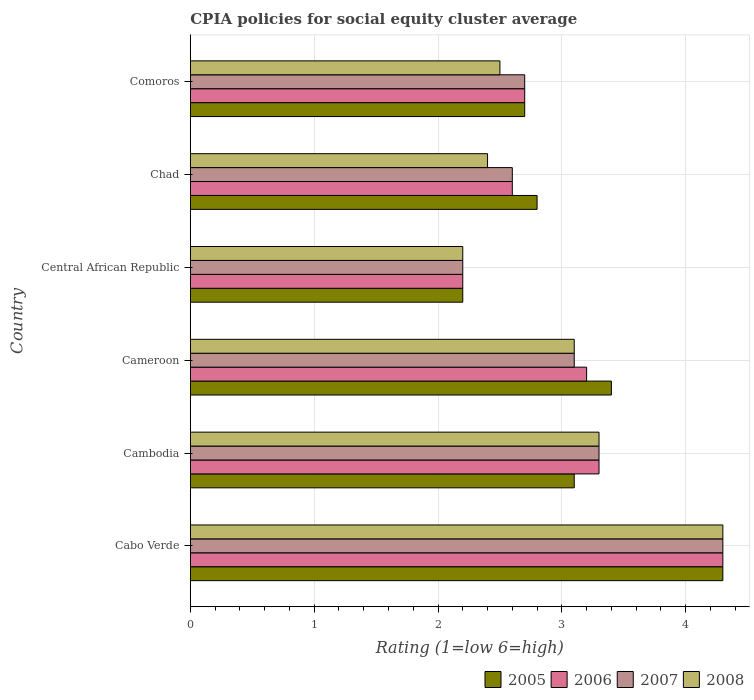How many different coloured bars are there?
Your answer should be very brief. 4. How many groups of bars are there?
Provide a short and direct response. 6. Are the number of bars per tick equal to the number of legend labels?
Ensure brevity in your answer.  Yes. How many bars are there on the 1st tick from the bottom?
Offer a terse response. 4. What is the label of the 2nd group of bars from the top?
Your response must be concise. Chad. In how many cases, is the number of bars for a given country not equal to the number of legend labels?
Provide a succinct answer. 0. What is the CPIA rating in 2007 in Cameroon?
Make the answer very short. 3.1. Across all countries, what is the maximum CPIA rating in 2005?
Your answer should be compact. 4.3. Across all countries, what is the minimum CPIA rating in 2006?
Make the answer very short. 2.2. In which country was the CPIA rating in 2008 maximum?
Your response must be concise. Cabo Verde. In which country was the CPIA rating in 2008 minimum?
Provide a short and direct response. Central African Republic. What is the total CPIA rating in 2008 in the graph?
Offer a very short reply. 17.8. What is the difference between the CPIA rating in 2008 in Cabo Verde and that in Central African Republic?
Offer a very short reply. 2.1. What is the difference between the CPIA rating in 2005 in Chad and the CPIA rating in 2007 in Cameroon?
Offer a terse response. -0.3. What is the average CPIA rating in 2006 per country?
Keep it short and to the point. 3.05. In how many countries, is the CPIA rating in 2005 greater than 2.8 ?
Provide a short and direct response. 3. What is the ratio of the CPIA rating in 2005 in Chad to that in Comoros?
Your answer should be compact. 1.04. Is the CPIA rating in 2007 in Cameroon less than that in Chad?
Offer a very short reply. No. Is the difference between the CPIA rating in 2006 in Cambodia and Cameroon greater than the difference between the CPIA rating in 2007 in Cambodia and Cameroon?
Your answer should be compact. No. What is the difference between the highest and the lowest CPIA rating in 2008?
Ensure brevity in your answer.  2.1. In how many countries, is the CPIA rating in 2007 greater than the average CPIA rating in 2007 taken over all countries?
Make the answer very short. 3. What does the 2nd bar from the top in Cameroon represents?
Keep it short and to the point. 2007. Are all the bars in the graph horizontal?
Provide a succinct answer. Yes. How many countries are there in the graph?
Give a very brief answer. 6. What is the difference between two consecutive major ticks on the X-axis?
Offer a very short reply. 1. Are the values on the major ticks of X-axis written in scientific E-notation?
Ensure brevity in your answer.  No. Does the graph contain any zero values?
Keep it short and to the point. No. Does the graph contain grids?
Your answer should be very brief. Yes. Where does the legend appear in the graph?
Give a very brief answer. Bottom right. How are the legend labels stacked?
Your answer should be compact. Horizontal. What is the title of the graph?
Give a very brief answer. CPIA policies for social equity cluster average. What is the label or title of the X-axis?
Your answer should be very brief. Rating (1=low 6=high). What is the Rating (1=low 6=high) of 2005 in Cabo Verde?
Your answer should be very brief. 4.3. What is the Rating (1=low 6=high) in 2006 in Cabo Verde?
Provide a short and direct response. 4.3. What is the Rating (1=low 6=high) in 2008 in Cabo Verde?
Keep it short and to the point. 4.3. What is the Rating (1=low 6=high) of 2005 in Cambodia?
Make the answer very short. 3.1. What is the Rating (1=low 6=high) of 2006 in Cambodia?
Ensure brevity in your answer.  3.3. What is the Rating (1=low 6=high) in 2007 in Cambodia?
Offer a terse response. 3.3. What is the Rating (1=low 6=high) in 2006 in Cameroon?
Ensure brevity in your answer.  3.2. What is the Rating (1=low 6=high) in 2005 in Central African Republic?
Provide a short and direct response. 2.2. What is the Rating (1=low 6=high) of 2005 in Chad?
Give a very brief answer. 2.8. What is the Rating (1=low 6=high) of 2006 in Chad?
Keep it short and to the point. 2.6. What is the Rating (1=low 6=high) in 2008 in Chad?
Make the answer very short. 2.4. What is the Rating (1=low 6=high) of 2005 in Comoros?
Your answer should be very brief. 2.7. What is the Rating (1=low 6=high) of 2006 in Comoros?
Your answer should be very brief. 2.7. What is the Rating (1=low 6=high) of 2007 in Comoros?
Your response must be concise. 2.7. What is the Rating (1=low 6=high) of 2008 in Comoros?
Make the answer very short. 2.5. Across all countries, what is the maximum Rating (1=low 6=high) of 2006?
Offer a very short reply. 4.3. Across all countries, what is the maximum Rating (1=low 6=high) of 2007?
Make the answer very short. 4.3. Across all countries, what is the maximum Rating (1=low 6=high) of 2008?
Provide a short and direct response. 4.3. Across all countries, what is the minimum Rating (1=low 6=high) of 2007?
Offer a terse response. 2.2. What is the total Rating (1=low 6=high) of 2005 in the graph?
Your response must be concise. 18.5. What is the total Rating (1=low 6=high) in 2007 in the graph?
Offer a very short reply. 18.2. What is the difference between the Rating (1=low 6=high) of 2006 in Cabo Verde and that in Cambodia?
Keep it short and to the point. 1. What is the difference between the Rating (1=low 6=high) of 2007 in Cabo Verde and that in Cambodia?
Your answer should be compact. 1. What is the difference between the Rating (1=low 6=high) in 2007 in Cabo Verde and that in Cameroon?
Offer a very short reply. 1.2. What is the difference between the Rating (1=low 6=high) in 2008 in Cabo Verde and that in Cameroon?
Ensure brevity in your answer.  1.2. What is the difference between the Rating (1=low 6=high) of 2008 in Cabo Verde and that in Central African Republic?
Provide a succinct answer. 2.1. What is the difference between the Rating (1=low 6=high) of 2005 in Cabo Verde and that in Chad?
Make the answer very short. 1.5. What is the difference between the Rating (1=low 6=high) of 2007 in Cabo Verde and that in Chad?
Your answer should be compact. 1.7. What is the difference between the Rating (1=low 6=high) of 2008 in Cabo Verde and that in Chad?
Offer a terse response. 1.9. What is the difference between the Rating (1=low 6=high) of 2006 in Cabo Verde and that in Comoros?
Give a very brief answer. 1.6. What is the difference between the Rating (1=low 6=high) in 2007 in Cabo Verde and that in Comoros?
Provide a short and direct response. 1.6. What is the difference between the Rating (1=low 6=high) in 2008 in Cabo Verde and that in Comoros?
Make the answer very short. 1.8. What is the difference between the Rating (1=low 6=high) of 2006 in Cambodia and that in Cameroon?
Provide a succinct answer. 0.1. What is the difference between the Rating (1=low 6=high) of 2008 in Cambodia and that in Cameroon?
Ensure brevity in your answer.  0.2. What is the difference between the Rating (1=low 6=high) of 2006 in Cambodia and that in Central African Republic?
Offer a very short reply. 1.1. What is the difference between the Rating (1=low 6=high) of 2007 in Cambodia and that in Central African Republic?
Provide a short and direct response. 1.1. What is the difference between the Rating (1=low 6=high) of 2008 in Cambodia and that in Central African Republic?
Your response must be concise. 1.1. What is the difference between the Rating (1=low 6=high) in 2008 in Cambodia and that in Chad?
Your response must be concise. 0.9. What is the difference between the Rating (1=low 6=high) in 2005 in Cambodia and that in Comoros?
Give a very brief answer. 0.4. What is the difference between the Rating (1=low 6=high) in 2005 in Cameroon and that in Central African Republic?
Keep it short and to the point. 1.2. What is the difference between the Rating (1=low 6=high) in 2007 in Cameroon and that in Central African Republic?
Give a very brief answer. 0.9. What is the difference between the Rating (1=low 6=high) of 2006 in Cameroon and that in Chad?
Your answer should be compact. 0.6. What is the difference between the Rating (1=low 6=high) of 2007 in Cameroon and that in Chad?
Make the answer very short. 0.5. What is the difference between the Rating (1=low 6=high) of 2007 in Cameroon and that in Comoros?
Give a very brief answer. 0.4. What is the difference between the Rating (1=low 6=high) of 2008 in Cameroon and that in Comoros?
Provide a short and direct response. 0.6. What is the difference between the Rating (1=low 6=high) of 2006 in Central African Republic and that in Chad?
Ensure brevity in your answer.  -0.4. What is the difference between the Rating (1=low 6=high) in 2007 in Central African Republic and that in Chad?
Provide a short and direct response. -0.4. What is the difference between the Rating (1=low 6=high) in 2006 in Central African Republic and that in Comoros?
Your answer should be compact. -0.5. What is the difference between the Rating (1=low 6=high) in 2005 in Chad and that in Comoros?
Your answer should be very brief. 0.1. What is the difference between the Rating (1=low 6=high) of 2006 in Chad and that in Comoros?
Give a very brief answer. -0.1. What is the difference between the Rating (1=low 6=high) in 2008 in Chad and that in Comoros?
Keep it short and to the point. -0.1. What is the difference between the Rating (1=low 6=high) in 2005 in Cabo Verde and the Rating (1=low 6=high) in 2007 in Cambodia?
Make the answer very short. 1. What is the difference between the Rating (1=low 6=high) in 2006 in Cabo Verde and the Rating (1=low 6=high) in 2008 in Cambodia?
Provide a succinct answer. 1. What is the difference between the Rating (1=low 6=high) of 2005 in Cabo Verde and the Rating (1=low 6=high) of 2006 in Cameroon?
Provide a short and direct response. 1.1. What is the difference between the Rating (1=low 6=high) in 2006 in Cabo Verde and the Rating (1=low 6=high) in 2008 in Cameroon?
Your answer should be very brief. 1.2. What is the difference between the Rating (1=low 6=high) of 2007 in Cabo Verde and the Rating (1=low 6=high) of 2008 in Cameroon?
Offer a terse response. 1.2. What is the difference between the Rating (1=low 6=high) in 2005 in Cabo Verde and the Rating (1=low 6=high) in 2007 in Central African Republic?
Your answer should be very brief. 2.1. What is the difference between the Rating (1=low 6=high) in 2005 in Cabo Verde and the Rating (1=low 6=high) in 2008 in Central African Republic?
Make the answer very short. 2.1. What is the difference between the Rating (1=low 6=high) of 2006 in Cabo Verde and the Rating (1=low 6=high) of 2007 in Central African Republic?
Provide a short and direct response. 2.1. What is the difference between the Rating (1=low 6=high) of 2006 in Cabo Verde and the Rating (1=low 6=high) of 2008 in Central African Republic?
Your answer should be very brief. 2.1. What is the difference between the Rating (1=low 6=high) of 2005 in Cabo Verde and the Rating (1=low 6=high) of 2008 in Chad?
Make the answer very short. 1.9. What is the difference between the Rating (1=low 6=high) of 2006 in Cabo Verde and the Rating (1=low 6=high) of 2007 in Chad?
Provide a short and direct response. 1.7. What is the difference between the Rating (1=low 6=high) in 2006 in Cabo Verde and the Rating (1=low 6=high) in 2008 in Chad?
Give a very brief answer. 1.9. What is the difference between the Rating (1=low 6=high) of 2005 in Cabo Verde and the Rating (1=low 6=high) of 2007 in Comoros?
Your answer should be very brief. 1.6. What is the difference between the Rating (1=low 6=high) in 2005 in Cabo Verde and the Rating (1=low 6=high) in 2008 in Comoros?
Your response must be concise. 1.8. What is the difference between the Rating (1=low 6=high) of 2006 in Cabo Verde and the Rating (1=low 6=high) of 2007 in Comoros?
Offer a terse response. 1.6. What is the difference between the Rating (1=low 6=high) of 2006 in Cambodia and the Rating (1=low 6=high) of 2008 in Cameroon?
Offer a terse response. 0.2. What is the difference between the Rating (1=low 6=high) in 2007 in Cambodia and the Rating (1=low 6=high) in 2008 in Cameroon?
Keep it short and to the point. 0.2. What is the difference between the Rating (1=low 6=high) of 2005 in Cambodia and the Rating (1=low 6=high) of 2008 in Central African Republic?
Your response must be concise. 0.9. What is the difference between the Rating (1=low 6=high) in 2006 in Cambodia and the Rating (1=low 6=high) in 2008 in Central African Republic?
Offer a very short reply. 1.1. What is the difference between the Rating (1=low 6=high) of 2005 in Cambodia and the Rating (1=low 6=high) of 2006 in Chad?
Your answer should be very brief. 0.5. What is the difference between the Rating (1=low 6=high) in 2005 in Cambodia and the Rating (1=low 6=high) in 2007 in Chad?
Provide a short and direct response. 0.5. What is the difference between the Rating (1=low 6=high) of 2005 in Cambodia and the Rating (1=low 6=high) of 2008 in Chad?
Give a very brief answer. 0.7. What is the difference between the Rating (1=low 6=high) of 2006 in Cambodia and the Rating (1=low 6=high) of 2008 in Chad?
Provide a short and direct response. 0.9. What is the difference between the Rating (1=low 6=high) of 2007 in Cambodia and the Rating (1=low 6=high) of 2008 in Chad?
Make the answer very short. 0.9. What is the difference between the Rating (1=low 6=high) in 2006 in Cambodia and the Rating (1=low 6=high) in 2007 in Comoros?
Your response must be concise. 0.6. What is the difference between the Rating (1=low 6=high) of 2005 in Cameroon and the Rating (1=low 6=high) of 2006 in Central African Republic?
Offer a very short reply. 1.2. What is the difference between the Rating (1=low 6=high) in 2005 in Cameroon and the Rating (1=low 6=high) in 2008 in Central African Republic?
Your answer should be compact. 1.2. What is the difference between the Rating (1=low 6=high) of 2006 in Cameroon and the Rating (1=low 6=high) of 2008 in Central African Republic?
Your answer should be very brief. 1. What is the difference between the Rating (1=low 6=high) of 2005 in Cameroon and the Rating (1=low 6=high) of 2007 in Chad?
Your answer should be very brief. 0.8. What is the difference between the Rating (1=low 6=high) in 2006 in Cameroon and the Rating (1=low 6=high) in 2008 in Chad?
Keep it short and to the point. 0.8. What is the difference between the Rating (1=low 6=high) of 2005 in Cameroon and the Rating (1=low 6=high) of 2007 in Comoros?
Provide a succinct answer. 0.7. What is the difference between the Rating (1=low 6=high) in 2005 in Central African Republic and the Rating (1=low 6=high) in 2006 in Chad?
Keep it short and to the point. -0.4. What is the difference between the Rating (1=low 6=high) of 2005 in Central African Republic and the Rating (1=low 6=high) of 2007 in Chad?
Provide a succinct answer. -0.4. What is the difference between the Rating (1=low 6=high) in 2005 in Central African Republic and the Rating (1=low 6=high) in 2008 in Chad?
Ensure brevity in your answer.  -0.2. What is the difference between the Rating (1=low 6=high) of 2006 in Central African Republic and the Rating (1=low 6=high) of 2007 in Chad?
Your response must be concise. -0.4. What is the difference between the Rating (1=low 6=high) in 2006 in Central African Republic and the Rating (1=low 6=high) in 2008 in Chad?
Provide a short and direct response. -0.2. What is the difference between the Rating (1=low 6=high) of 2007 in Central African Republic and the Rating (1=low 6=high) of 2008 in Chad?
Keep it short and to the point. -0.2. What is the difference between the Rating (1=low 6=high) of 2005 in Central African Republic and the Rating (1=low 6=high) of 2006 in Comoros?
Your response must be concise. -0.5. What is the difference between the Rating (1=low 6=high) of 2005 in Central African Republic and the Rating (1=low 6=high) of 2007 in Comoros?
Provide a succinct answer. -0.5. What is the difference between the Rating (1=low 6=high) in 2006 in Central African Republic and the Rating (1=low 6=high) in 2007 in Comoros?
Your response must be concise. -0.5. What is the difference between the Rating (1=low 6=high) of 2005 in Chad and the Rating (1=low 6=high) of 2007 in Comoros?
Your answer should be very brief. 0.1. What is the difference between the Rating (1=low 6=high) in 2005 in Chad and the Rating (1=low 6=high) in 2008 in Comoros?
Keep it short and to the point. 0.3. What is the difference between the Rating (1=low 6=high) of 2006 in Chad and the Rating (1=low 6=high) of 2008 in Comoros?
Provide a short and direct response. 0.1. What is the average Rating (1=low 6=high) of 2005 per country?
Your response must be concise. 3.08. What is the average Rating (1=low 6=high) in 2006 per country?
Your response must be concise. 3.05. What is the average Rating (1=low 6=high) in 2007 per country?
Ensure brevity in your answer.  3.03. What is the average Rating (1=low 6=high) in 2008 per country?
Offer a terse response. 2.97. What is the difference between the Rating (1=low 6=high) of 2005 and Rating (1=low 6=high) of 2006 in Cabo Verde?
Offer a very short reply. 0. What is the difference between the Rating (1=low 6=high) of 2005 and Rating (1=low 6=high) of 2007 in Cabo Verde?
Keep it short and to the point. 0. What is the difference between the Rating (1=low 6=high) of 2005 and Rating (1=low 6=high) of 2008 in Cabo Verde?
Your answer should be compact. 0. What is the difference between the Rating (1=low 6=high) of 2006 and Rating (1=low 6=high) of 2007 in Cabo Verde?
Offer a very short reply. 0. What is the difference between the Rating (1=low 6=high) of 2006 and Rating (1=low 6=high) of 2008 in Cabo Verde?
Your response must be concise. 0. What is the difference between the Rating (1=low 6=high) of 2007 and Rating (1=low 6=high) of 2008 in Cabo Verde?
Ensure brevity in your answer.  0. What is the difference between the Rating (1=low 6=high) of 2005 and Rating (1=low 6=high) of 2006 in Cambodia?
Ensure brevity in your answer.  -0.2. What is the difference between the Rating (1=low 6=high) of 2005 and Rating (1=low 6=high) of 2008 in Cambodia?
Offer a terse response. -0.2. What is the difference between the Rating (1=low 6=high) of 2007 and Rating (1=low 6=high) of 2008 in Cambodia?
Your answer should be very brief. 0. What is the difference between the Rating (1=low 6=high) of 2005 and Rating (1=low 6=high) of 2006 in Cameroon?
Make the answer very short. 0.2. What is the difference between the Rating (1=low 6=high) in 2005 and Rating (1=low 6=high) in 2007 in Cameroon?
Provide a succinct answer. 0.3. What is the difference between the Rating (1=low 6=high) in 2005 and Rating (1=low 6=high) in 2008 in Cameroon?
Offer a very short reply. 0.3. What is the difference between the Rating (1=low 6=high) in 2006 and Rating (1=low 6=high) in 2007 in Cameroon?
Offer a very short reply. 0.1. What is the difference between the Rating (1=low 6=high) of 2007 and Rating (1=low 6=high) of 2008 in Cameroon?
Provide a succinct answer. 0. What is the difference between the Rating (1=low 6=high) of 2005 and Rating (1=low 6=high) of 2006 in Central African Republic?
Provide a succinct answer. 0. What is the difference between the Rating (1=low 6=high) of 2005 and Rating (1=low 6=high) of 2007 in Central African Republic?
Give a very brief answer. 0. What is the difference between the Rating (1=low 6=high) of 2005 and Rating (1=low 6=high) of 2008 in Central African Republic?
Make the answer very short. 0. What is the difference between the Rating (1=low 6=high) of 2007 and Rating (1=low 6=high) of 2008 in Central African Republic?
Your response must be concise. 0. What is the difference between the Rating (1=low 6=high) in 2005 and Rating (1=low 6=high) in 2006 in Chad?
Give a very brief answer. 0.2. What is the difference between the Rating (1=low 6=high) of 2005 and Rating (1=low 6=high) of 2008 in Chad?
Your answer should be compact. 0.4. What is the difference between the Rating (1=low 6=high) in 2006 and Rating (1=low 6=high) in 2008 in Chad?
Provide a succinct answer. 0.2. What is the difference between the Rating (1=low 6=high) of 2007 and Rating (1=low 6=high) of 2008 in Chad?
Your answer should be compact. 0.2. What is the difference between the Rating (1=low 6=high) in 2005 and Rating (1=low 6=high) in 2006 in Comoros?
Offer a terse response. 0. What is the difference between the Rating (1=low 6=high) of 2005 and Rating (1=low 6=high) of 2008 in Comoros?
Ensure brevity in your answer.  0.2. What is the difference between the Rating (1=low 6=high) of 2006 and Rating (1=low 6=high) of 2008 in Comoros?
Provide a succinct answer. 0.2. What is the difference between the Rating (1=low 6=high) of 2007 and Rating (1=low 6=high) of 2008 in Comoros?
Provide a short and direct response. 0.2. What is the ratio of the Rating (1=low 6=high) in 2005 in Cabo Verde to that in Cambodia?
Provide a succinct answer. 1.39. What is the ratio of the Rating (1=low 6=high) of 2006 in Cabo Verde to that in Cambodia?
Make the answer very short. 1.3. What is the ratio of the Rating (1=low 6=high) in 2007 in Cabo Verde to that in Cambodia?
Offer a terse response. 1.3. What is the ratio of the Rating (1=low 6=high) of 2008 in Cabo Verde to that in Cambodia?
Give a very brief answer. 1.3. What is the ratio of the Rating (1=low 6=high) of 2005 in Cabo Verde to that in Cameroon?
Give a very brief answer. 1.26. What is the ratio of the Rating (1=low 6=high) in 2006 in Cabo Verde to that in Cameroon?
Keep it short and to the point. 1.34. What is the ratio of the Rating (1=low 6=high) in 2007 in Cabo Verde to that in Cameroon?
Your answer should be very brief. 1.39. What is the ratio of the Rating (1=low 6=high) in 2008 in Cabo Verde to that in Cameroon?
Provide a succinct answer. 1.39. What is the ratio of the Rating (1=low 6=high) of 2005 in Cabo Verde to that in Central African Republic?
Give a very brief answer. 1.95. What is the ratio of the Rating (1=low 6=high) in 2006 in Cabo Verde to that in Central African Republic?
Your answer should be very brief. 1.95. What is the ratio of the Rating (1=low 6=high) in 2007 in Cabo Verde to that in Central African Republic?
Ensure brevity in your answer.  1.95. What is the ratio of the Rating (1=low 6=high) of 2008 in Cabo Verde to that in Central African Republic?
Keep it short and to the point. 1.95. What is the ratio of the Rating (1=low 6=high) of 2005 in Cabo Verde to that in Chad?
Provide a short and direct response. 1.54. What is the ratio of the Rating (1=low 6=high) of 2006 in Cabo Verde to that in Chad?
Your response must be concise. 1.65. What is the ratio of the Rating (1=low 6=high) of 2007 in Cabo Verde to that in Chad?
Your answer should be very brief. 1.65. What is the ratio of the Rating (1=low 6=high) in 2008 in Cabo Verde to that in Chad?
Offer a very short reply. 1.79. What is the ratio of the Rating (1=low 6=high) of 2005 in Cabo Verde to that in Comoros?
Provide a short and direct response. 1.59. What is the ratio of the Rating (1=low 6=high) in 2006 in Cabo Verde to that in Comoros?
Your answer should be very brief. 1.59. What is the ratio of the Rating (1=low 6=high) of 2007 in Cabo Verde to that in Comoros?
Provide a short and direct response. 1.59. What is the ratio of the Rating (1=low 6=high) of 2008 in Cabo Verde to that in Comoros?
Give a very brief answer. 1.72. What is the ratio of the Rating (1=low 6=high) in 2005 in Cambodia to that in Cameroon?
Give a very brief answer. 0.91. What is the ratio of the Rating (1=low 6=high) in 2006 in Cambodia to that in Cameroon?
Ensure brevity in your answer.  1.03. What is the ratio of the Rating (1=low 6=high) in 2007 in Cambodia to that in Cameroon?
Your response must be concise. 1.06. What is the ratio of the Rating (1=low 6=high) in 2008 in Cambodia to that in Cameroon?
Give a very brief answer. 1.06. What is the ratio of the Rating (1=low 6=high) in 2005 in Cambodia to that in Central African Republic?
Offer a terse response. 1.41. What is the ratio of the Rating (1=low 6=high) in 2008 in Cambodia to that in Central African Republic?
Make the answer very short. 1.5. What is the ratio of the Rating (1=low 6=high) of 2005 in Cambodia to that in Chad?
Your response must be concise. 1.11. What is the ratio of the Rating (1=low 6=high) in 2006 in Cambodia to that in Chad?
Your answer should be very brief. 1.27. What is the ratio of the Rating (1=low 6=high) of 2007 in Cambodia to that in Chad?
Offer a terse response. 1.27. What is the ratio of the Rating (1=low 6=high) of 2008 in Cambodia to that in Chad?
Give a very brief answer. 1.38. What is the ratio of the Rating (1=low 6=high) in 2005 in Cambodia to that in Comoros?
Provide a succinct answer. 1.15. What is the ratio of the Rating (1=low 6=high) in 2006 in Cambodia to that in Comoros?
Keep it short and to the point. 1.22. What is the ratio of the Rating (1=low 6=high) in 2007 in Cambodia to that in Comoros?
Offer a terse response. 1.22. What is the ratio of the Rating (1=low 6=high) in 2008 in Cambodia to that in Comoros?
Provide a short and direct response. 1.32. What is the ratio of the Rating (1=low 6=high) in 2005 in Cameroon to that in Central African Republic?
Provide a short and direct response. 1.55. What is the ratio of the Rating (1=low 6=high) in 2006 in Cameroon to that in Central African Republic?
Offer a terse response. 1.45. What is the ratio of the Rating (1=low 6=high) in 2007 in Cameroon to that in Central African Republic?
Offer a very short reply. 1.41. What is the ratio of the Rating (1=low 6=high) in 2008 in Cameroon to that in Central African Republic?
Ensure brevity in your answer.  1.41. What is the ratio of the Rating (1=low 6=high) in 2005 in Cameroon to that in Chad?
Your answer should be compact. 1.21. What is the ratio of the Rating (1=low 6=high) of 2006 in Cameroon to that in Chad?
Ensure brevity in your answer.  1.23. What is the ratio of the Rating (1=low 6=high) of 2007 in Cameroon to that in Chad?
Your answer should be compact. 1.19. What is the ratio of the Rating (1=low 6=high) in 2008 in Cameroon to that in Chad?
Keep it short and to the point. 1.29. What is the ratio of the Rating (1=low 6=high) in 2005 in Cameroon to that in Comoros?
Provide a succinct answer. 1.26. What is the ratio of the Rating (1=low 6=high) in 2006 in Cameroon to that in Comoros?
Your answer should be compact. 1.19. What is the ratio of the Rating (1=low 6=high) of 2007 in Cameroon to that in Comoros?
Your answer should be very brief. 1.15. What is the ratio of the Rating (1=low 6=high) of 2008 in Cameroon to that in Comoros?
Offer a terse response. 1.24. What is the ratio of the Rating (1=low 6=high) of 2005 in Central African Republic to that in Chad?
Your answer should be very brief. 0.79. What is the ratio of the Rating (1=low 6=high) in 2006 in Central African Republic to that in Chad?
Offer a very short reply. 0.85. What is the ratio of the Rating (1=low 6=high) of 2007 in Central African Republic to that in Chad?
Offer a terse response. 0.85. What is the ratio of the Rating (1=low 6=high) of 2008 in Central African Republic to that in Chad?
Your response must be concise. 0.92. What is the ratio of the Rating (1=low 6=high) in 2005 in Central African Republic to that in Comoros?
Offer a terse response. 0.81. What is the ratio of the Rating (1=low 6=high) of 2006 in Central African Republic to that in Comoros?
Your answer should be compact. 0.81. What is the ratio of the Rating (1=low 6=high) in 2007 in Central African Republic to that in Comoros?
Ensure brevity in your answer.  0.81. What is the ratio of the Rating (1=low 6=high) of 2008 in Central African Republic to that in Comoros?
Give a very brief answer. 0.88. What is the ratio of the Rating (1=low 6=high) in 2005 in Chad to that in Comoros?
Offer a terse response. 1.04. What is the ratio of the Rating (1=low 6=high) of 2006 in Chad to that in Comoros?
Provide a succinct answer. 0.96. What is the ratio of the Rating (1=low 6=high) in 2007 in Chad to that in Comoros?
Keep it short and to the point. 0.96. What is the difference between the highest and the second highest Rating (1=low 6=high) in 2005?
Ensure brevity in your answer.  0.9. What is the difference between the highest and the second highest Rating (1=low 6=high) of 2006?
Your answer should be compact. 1. What is the difference between the highest and the second highest Rating (1=low 6=high) in 2007?
Your answer should be very brief. 1. What is the difference between the highest and the second highest Rating (1=low 6=high) of 2008?
Ensure brevity in your answer.  1. What is the difference between the highest and the lowest Rating (1=low 6=high) of 2005?
Ensure brevity in your answer.  2.1. What is the difference between the highest and the lowest Rating (1=low 6=high) of 2006?
Offer a terse response. 2.1. What is the difference between the highest and the lowest Rating (1=low 6=high) in 2007?
Give a very brief answer. 2.1. What is the difference between the highest and the lowest Rating (1=low 6=high) of 2008?
Offer a terse response. 2.1. 